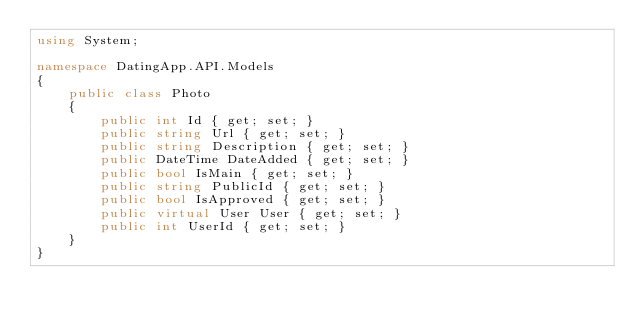Convert code to text. <code><loc_0><loc_0><loc_500><loc_500><_C#_>using System;

namespace DatingApp.API.Models
{
    public class Photo
    {
        public int Id { get; set; }
        public string Url { get; set; }
        public string Description { get; set; }
        public DateTime DateAdded { get; set; }
        public bool IsMain { get; set; }
        public string PublicId { get; set; }
        public bool IsApproved { get; set; }
        public virtual User User { get; set; }
        public int UserId { get; set; }
    }
}</code> 